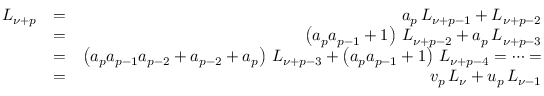<formula> <loc_0><loc_0><loc_500><loc_500>\begin{array} { r l r } { L _ { \nu + p } } & { = } & { a _ { p } \, L _ { \nu + p - 1 } + L _ { \nu + p - 2 } } \\ & { = } & { \left ( a _ { p } a _ { p - 1 } + 1 \right ) \, L _ { \nu + p - 2 } + a _ { p } \, L _ { \nu + p - 3 } } \\ & { = } & { \left ( a _ { p } a _ { p - 1 } a _ { p - 2 } + a _ { p - 2 } + a _ { p } \right ) \, L _ { \nu + p - 3 } + \left ( a _ { p } a _ { p - 1 } + 1 \right ) \, L _ { \nu + p - 4 } = \cdots = } \\ & { = } & { v _ { p } \, L _ { \nu } + u _ { p } \, L _ { \nu - 1 } } \end{array}</formula> 